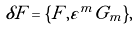Convert formula to latex. <formula><loc_0><loc_0><loc_500><loc_500>\delta F = \{ F , \varepsilon ^ { m } G _ { m } \} ,</formula> 